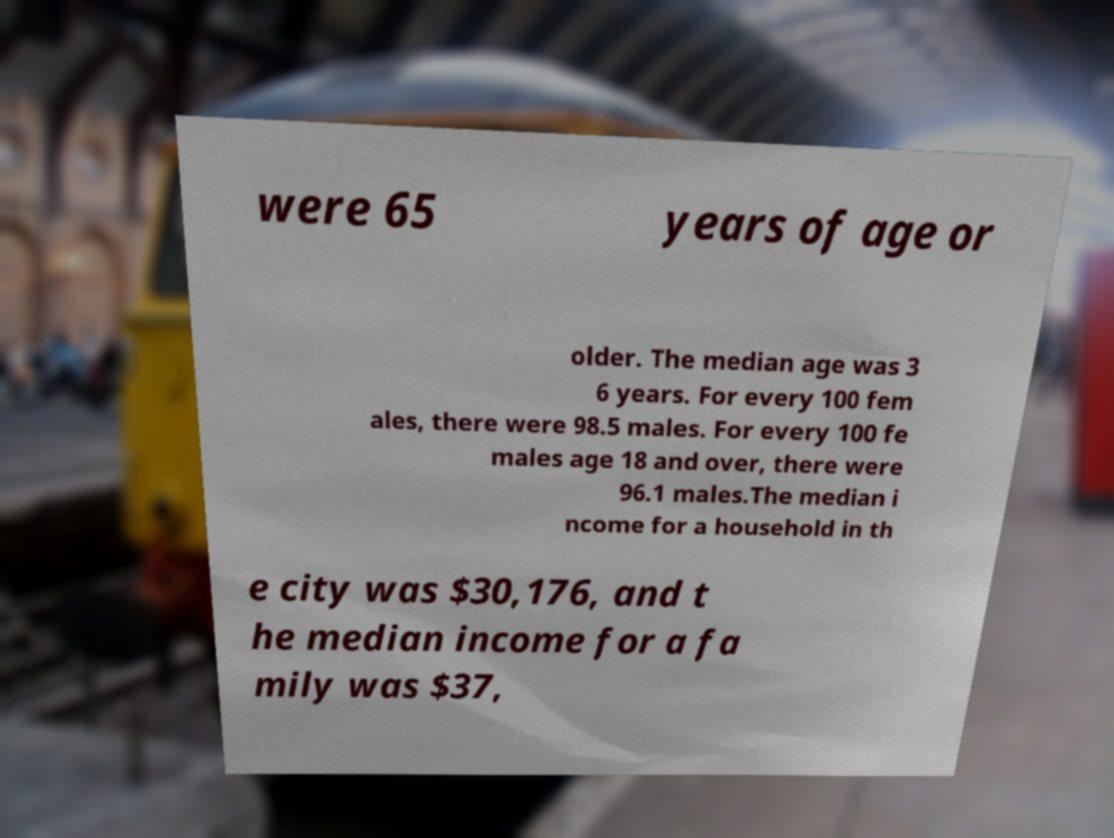Can you accurately transcribe the text from the provided image for me? were 65 years of age or older. The median age was 3 6 years. For every 100 fem ales, there were 98.5 males. For every 100 fe males age 18 and over, there were 96.1 males.The median i ncome for a household in th e city was $30,176, and t he median income for a fa mily was $37, 